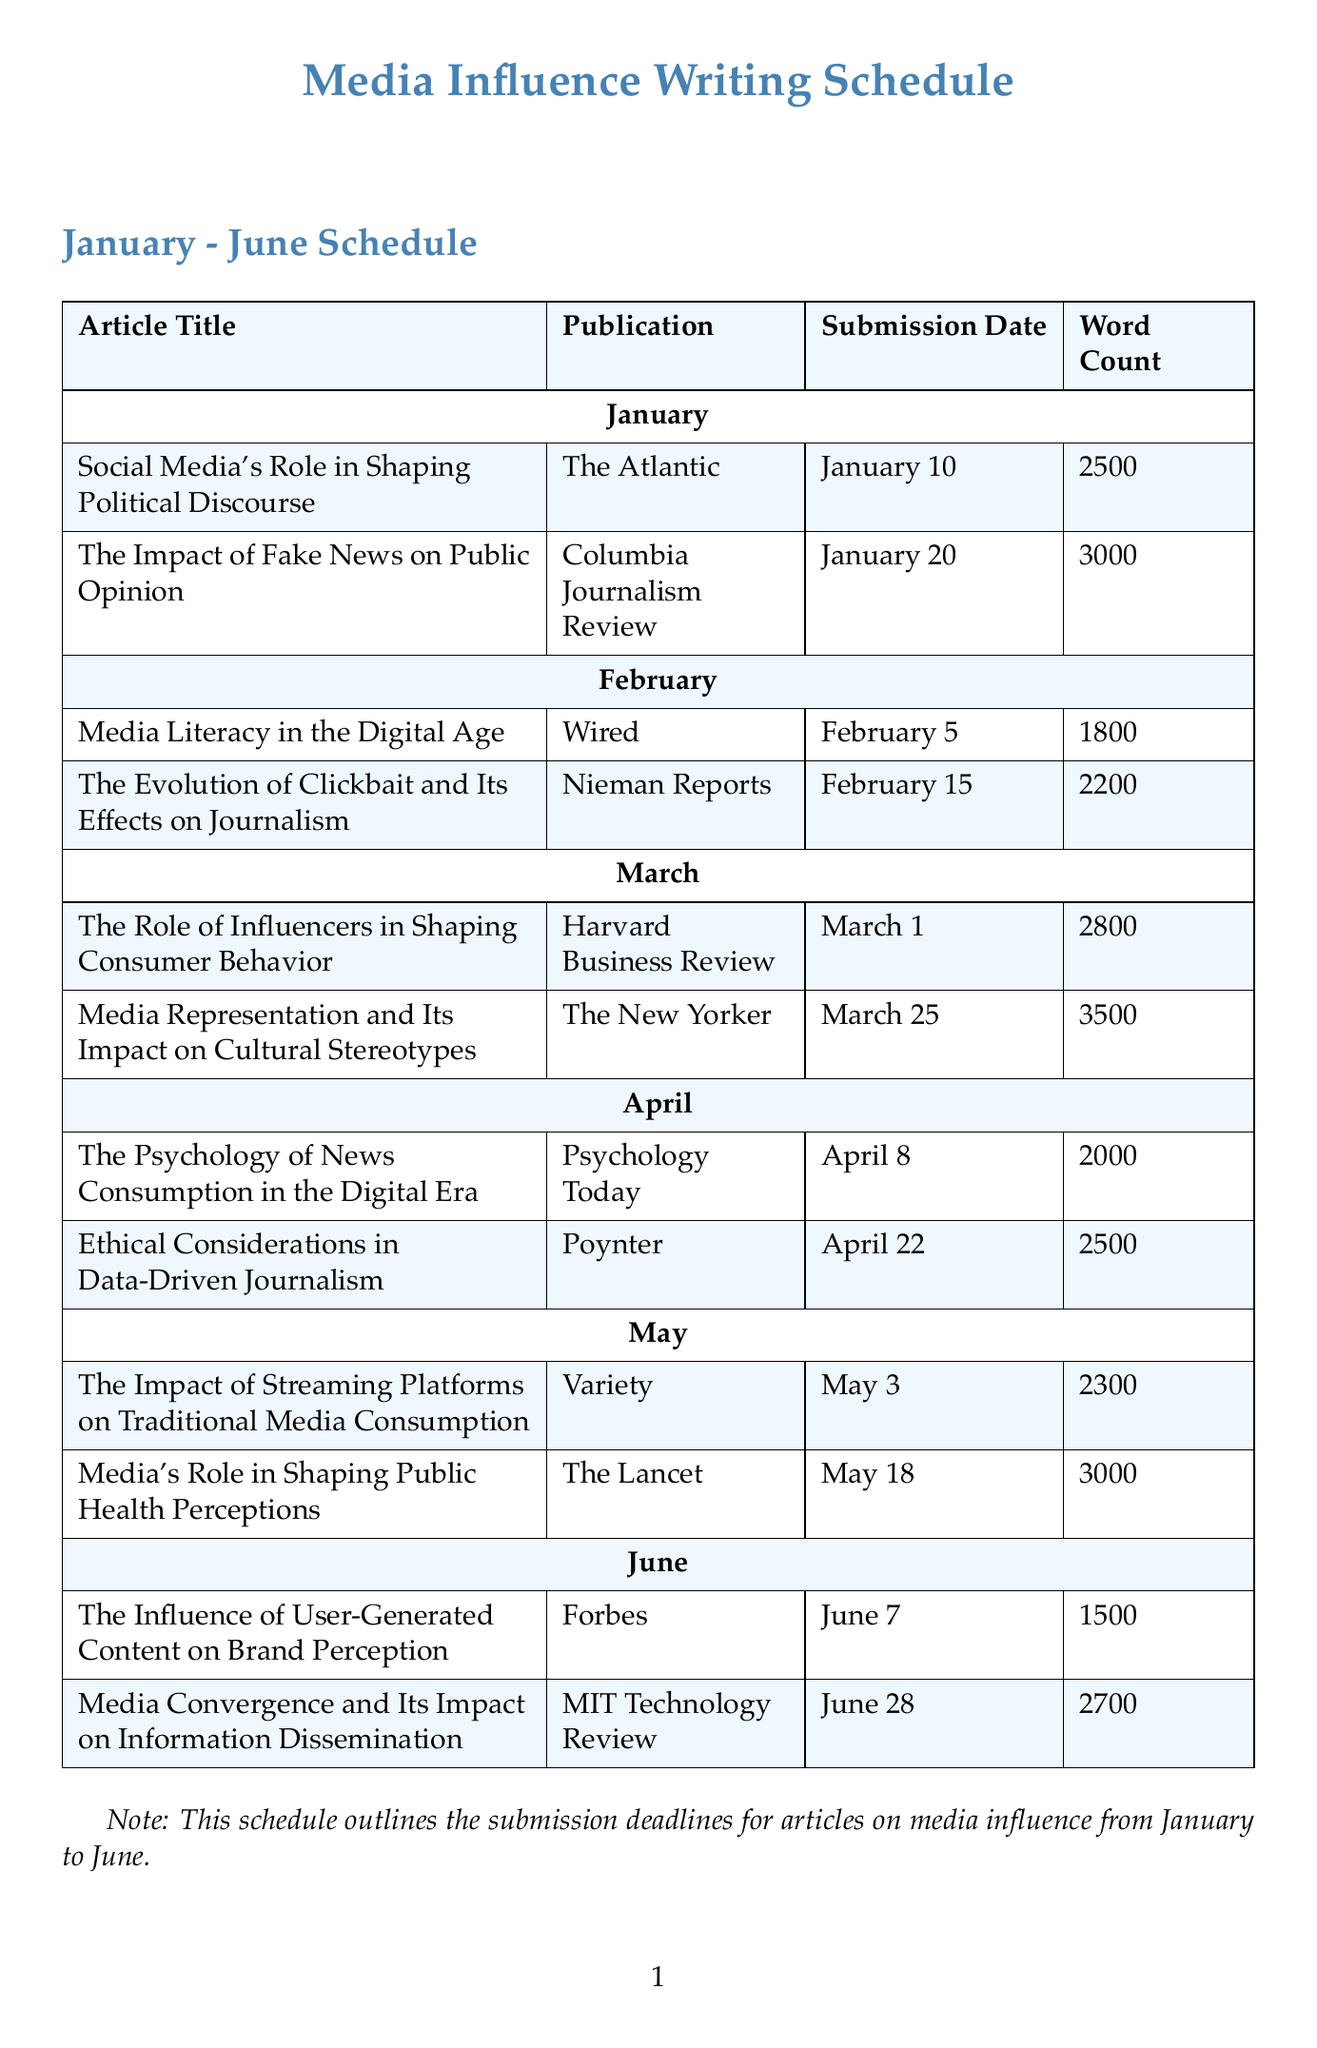what is the first article due in January? The title of the first article in January is listed at the top of the section for that month.
Answer: Social Media's Role in Shaping Political Discourse which publication is associated with the article "The Impact of Fake News on Public Opinion"? The publication for this article is indicated next to the title under January.
Answer: Columbia Journalism Review what is the word count for the article due in March titled "Media Representation and Its Impact on Cultural Stereotypes"? The word count is provided in the schedule next to the article title for March.
Answer: 3500 when is the submission date for the article "Ethical Considerations in Data-Driven Journalism"? This date is displayed in the submission date column for April articles.
Answer: April 22 what is the total number of articles listed for June? The count of articles is found by reviewing the article section for June in the schedule.
Answer: 2 which month has the earliest submission deadline, and what is the date? The earliest submission deadline is found by examining the submission dates in the schedule.
Answer: January, January 10 how many words are in the article "The Influence of User-Generated Content on Brand Perception"? The word count is noted next to the article's title in the June section.
Answer: 1500 which article has the longest word count and what is its title? The longest word count is identified by comparing all word counts listed in the document.
Answer: Media Representation and Its Impact on Cultural Stereotypes, 3500 